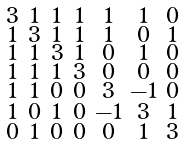Convert formula to latex. <formula><loc_0><loc_0><loc_500><loc_500>\begin{smallmatrix} 3 & 1 & 1 & 1 & 1 & 1 & 0 \\ 1 & 3 & 1 & 1 & 1 & 0 & 1 \\ 1 & 1 & 3 & 1 & 0 & 1 & 0 \\ 1 & 1 & 1 & 3 & 0 & 0 & 0 \\ 1 & 1 & 0 & 0 & 3 & - 1 & 0 \\ 1 & 0 & 1 & 0 & - 1 & 3 & 1 \\ 0 & 1 & 0 & 0 & 0 & 1 & 3 \end{smallmatrix}</formula> 